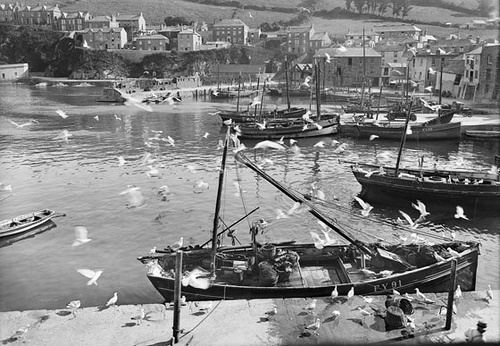Describe the objects in this image and their specific colors. I can see boat in gray, black, darkgray, and lightgray tones, boat in gray, black, darkgray, and lightgray tones, bird in gray, darkgray, lightgray, and black tones, boat in gray, black, darkgray, and lightgray tones, and boat in gray, black, darkgray, and lightgray tones in this image. 